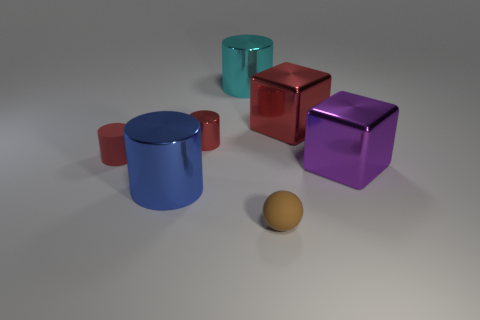Subtract all blue cylinders. How many cylinders are left? 3 Subtract all brown cylinders. Subtract all cyan spheres. How many cylinders are left? 4 Add 2 matte cylinders. How many objects exist? 9 Subtract all blocks. How many objects are left? 5 Add 2 purple cubes. How many purple cubes exist? 3 Subtract 0 brown cylinders. How many objects are left? 7 Subtract all big cyan metal cylinders. Subtract all big red metallic blocks. How many objects are left? 5 Add 1 small matte cylinders. How many small matte cylinders are left? 2 